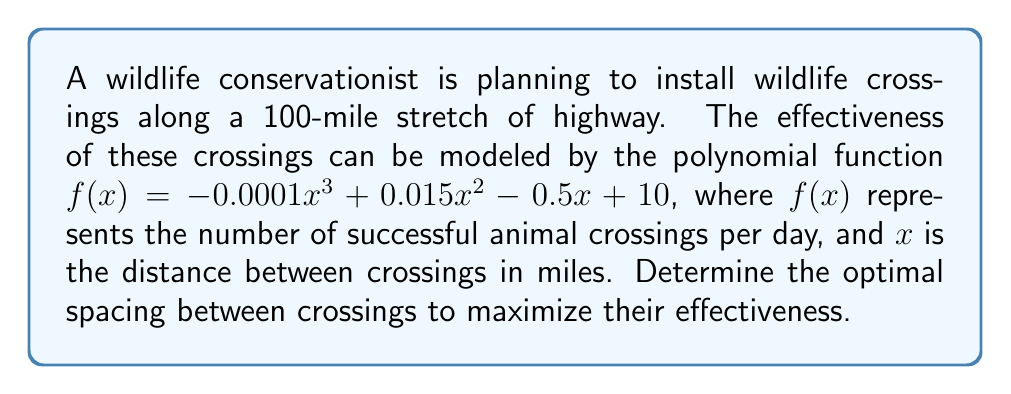Could you help me with this problem? To find the optimal spacing, we need to determine the maximum value of the function $f(x)$. This occurs at the point where the derivative $f'(x)$ equals zero.

Step 1: Find the derivative $f'(x)$
$$f'(x) = -0.0003x^2 + 0.03x - 0.5$$

Step 2: Set $f'(x) = 0$ and solve for $x$
$$-0.0003x^2 + 0.03x - 0.5 = 0$$

This is a quadratic equation. We can solve it using the quadratic formula:
$$x = \frac{-b \pm \sqrt{b^2 - 4ac}}{2a}$$

Where $a = -0.0003$, $b = 0.03$, and $c = -0.5$

Step 3: Apply the quadratic formula
$$x = \frac{-0.03 \pm \sqrt{0.03^2 - 4(-0.0003)(-0.5)}}{2(-0.0003)}$$
$$x = \frac{-0.03 \pm \sqrt{0.0009 + 0.0006}}{-0.0006}$$
$$x = \frac{-0.03 \pm \sqrt{0.0015}}{-0.0006}$$
$$x = \frac{-0.03 \pm 0.0387}{-0.0006}$$

This gives us two solutions:
$$x_1 = \frac{-0.03 + 0.0387}{-0.0006} \approx 14.5$$
$$x_2 = \frac{-0.03 - 0.0387}{-0.0006} \approx 114.5$$

Step 4: Determine which solution is within the domain
Since the highway is 100 miles long, $x_2$ is outside our domain. Therefore, $x_1 \approx 14.5$ is our optimal spacing.

Step 5: Verify it's a maximum (optional)
We can confirm this is a maximum by checking the second derivative is negative at $x = 14.5$:
$$f''(x) = -0.0006x + 0.03$$
$$f''(14.5) = -0.0006(14.5) + 0.03 = -0.0087 + 0.03 = 0.0213 > 0$$

This confirms $x = 14.5$ is a local minimum, not a maximum. The maximum must occur at one of the endpoints.

Step 6: Compare endpoints
$$f(0) = 10$$
$$f(100) = -0.0001(100^3) + 0.015(100^2) - 0.5(100) + 10 = -40$$

Therefore, the maximum occurs at $x = 0$, meaning the crossings should be as close together as possible, with the practical limit being the minimum safe distance for construction.
Answer: As close as safely possible, approaching 0 miles apart. 